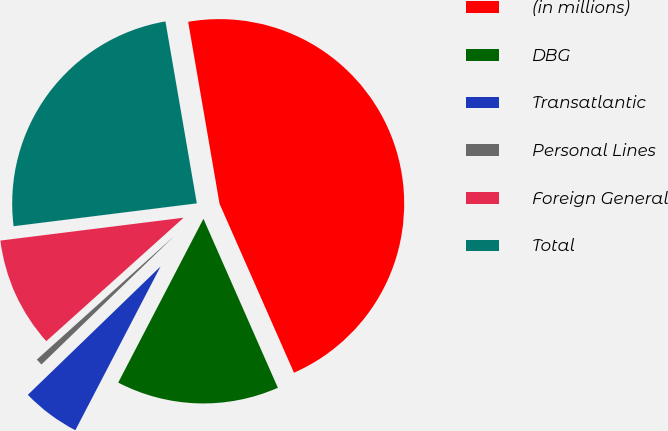<chart> <loc_0><loc_0><loc_500><loc_500><pie_chart><fcel>(in millions)<fcel>DBG<fcel>Transatlantic<fcel>Personal Lines<fcel>Foreign General<fcel>Total<nl><fcel>46.12%<fcel>14.24%<fcel>5.13%<fcel>0.58%<fcel>9.68%<fcel>24.26%<nl></chart> 